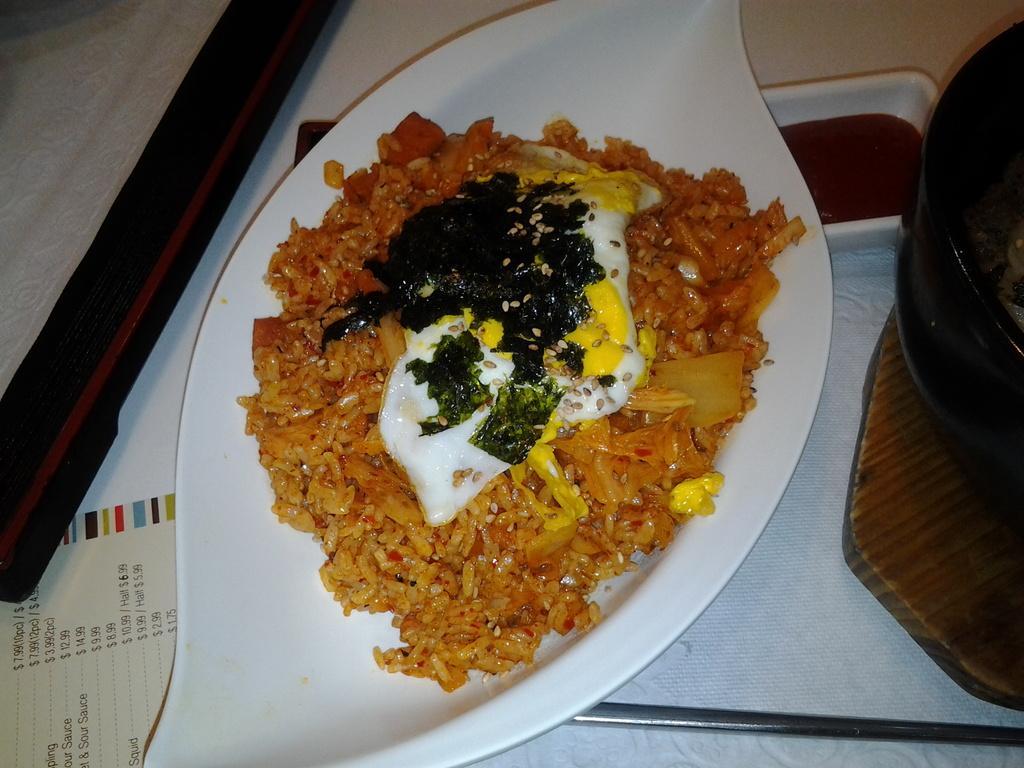Describe this image in one or two sentences. In this image there is a table with a menu card and a tray on it. There is a plate with an omelet and a food item on the tray and there is a bowl with a food item. 